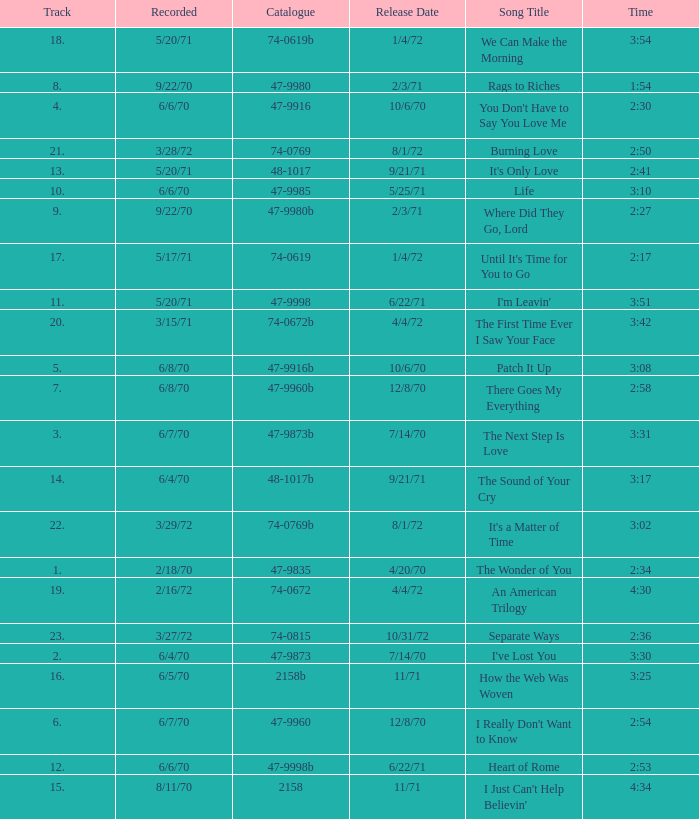Write the full table. {'header': ['Track', 'Recorded', 'Catalogue', 'Release Date', 'Song Title', 'Time'], 'rows': [['18.', '5/20/71', '74-0619b', '1/4/72', 'We Can Make the Morning', '3:54'], ['8.', '9/22/70', '47-9980', '2/3/71', 'Rags to Riches', '1:54'], ['4.', '6/6/70', '47-9916', '10/6/70', "You Don't Have to Say You Love Me", '2:30'], ['21.', '3/28/72', '74-0769', '8/1/72', 'Burning Love', '2:50'], ['13.', '5/20/71', '48-1017', '9/21/71', "It's Only Love", '2:41'], ['10.', '6/6/70', '47-9985', '5/25/71', 'Life', '3:10'], ['9.', '9/22/70', '47-9980b', '2/3/71', 'Where Did They Go, Lord', '2:27'], ['17.', '5/17/71', '74-0619', '1/4/72', "Until It's Time for You to Go", '2:17'], ['11.', '5/20/71', '47-9998', '6/22/71', "I'm Leavin'", '3:51'], ['20.', '3/15/71', '74-0672b', '4/4/72', 'The First Time Ever I Saw Your Face', '3:42'], ['5.', '6/8/70', '47-9916b', '10/6/70', 'Patch It Up', '3:08'], ['7.', '6/8/70', '47-9960b', '12/8/70', 'There Goes My Everything', '2:58'], ['3.', '6/7/70', '47-9873b', '7/14/70', 'The Next Step Is Love', '3:31'], ['14.', '6/4/70', '48-1017b', '9/21/71', 'The Sound of Your Cry', '3:17'], ['22.', '3/29/72', '74-0769b', '8/1/72', "It's a Matter of Time", '3:02'], ['1.', '2/18/70', '47-9835', '4/20/70', 'The Wonder of You', '2:34'], ['19.', '2/16/72', '74-0672', '4/4/72', 'An American Trilogy', '4:30'], ['23.', '3/27/72', '74-0815', '10/31/72', 'Separate Ways', '2:36'], ['2.', '6/4/70', '47-9873', '7/14/70', "I've Lost You", '3:30'], ['16.', '6/5/70', '2158b', '11/71', 'How the Web Was Woven', '3:25'], ['6.', '6/7/70', '47-9960', '12/8/70', "I Really Don't Want to Know", '2:54'], ['12.', '6/6/70', '47-9998b', '6/22/71', 'Heart of Rome', '2:53'], ['15.', '8/11/70', '2158', '11/71', "I Just Can't Help Believin'", '4:34']]} What is Heart of Rome's catalogue number? 47-9998b. 